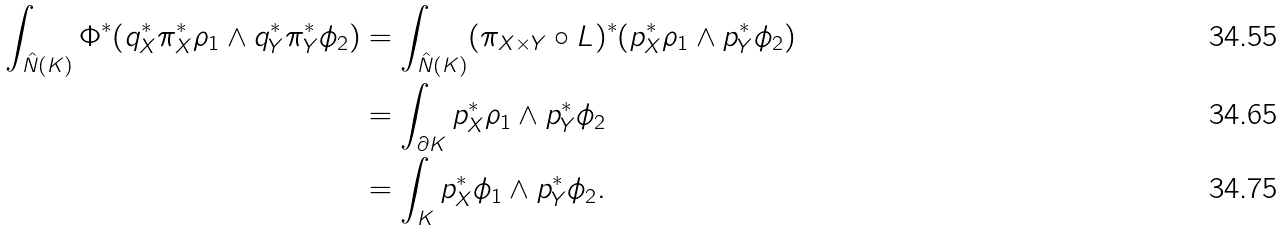<formula> <loc_0><loc_0><loc_500><loc_500>\int _ { \hat { N } ( K ) } \Phi ^ { * } ( q _ { X } ^ { * } \pi _ { X } ^ { * } \rho _ { 1 } \wedge q _ { Y } ^ { * } \pi _ { Y } ^ { * } \phi _ { 2 } ) & = \int _ { \hat { N } ( K ) } ( \pi _ { X \times Y } \circ L ) ^ { * } ( p _ { X } ^ { * } \rho _ { 1 } \wedge p _ { Y } ^ { * } \phi _ { 2 } ) \\ & = \int _ { \partial K } p _ { X } ^ { * } \rho _ { 1 } \wedge p _ { Y } ^ { * } \phi _ { 2 } \\ & = \int _ { K } p _ { X } ^ { * } \phi _ { 1 } \wedge p _ { Y } ^ { * } \phi _ { 2 } .</formula> 